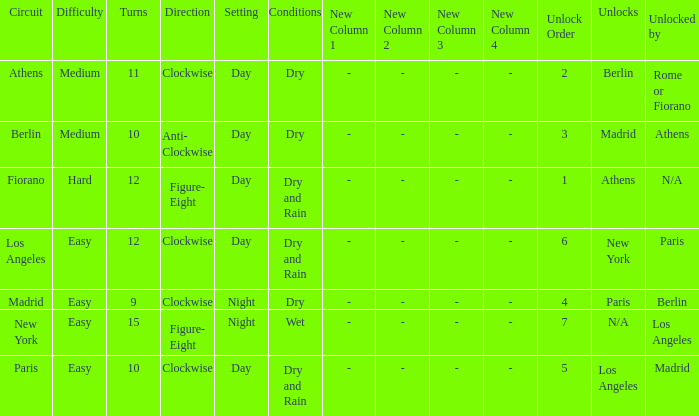How many instances is paris the unlock? 1.0. 